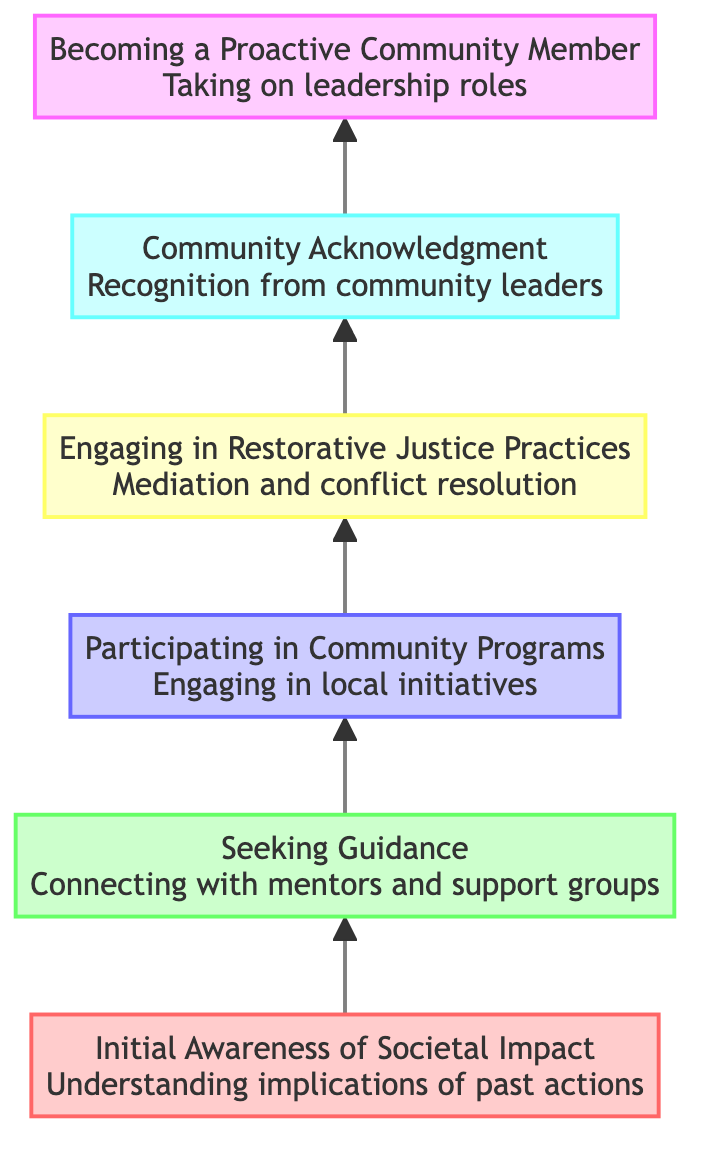What is the title of the top node in the diagram? The top node in the diagram represents the final step in the flow, which is "Becoming a Proactive Community Member"
Answer: Becoming a Proactive Community Member How many levels are represented in the diagram? The diagram consists of six distinct levels, ranging from 'Initial Awareness of Societal Impact' to 'Becoming a Proactive Community Member'
Answer: 6 What process directly follows "Engaging in Restorative Justice Practices"? The node that follows "Engaging in Restorative Justice Practices" in the upward flow is "Community Acknowledgment"
Answer: Community Acknowledgment Which node addresses community service programs? The node that focuses on community service initiatives is "Participating in Community Programs," which includes local initiatives and mentorship
Answer: Participating in Community Programs What is the main action represented at level 5 of the diagram? At level 5 of the diagram, the main action is "Community Acknowledgment," which involves receiving recognition from community leaders
Answer: Community Acknowledgment What is the first step in the process depicted in the diagram? The first step in the flow of the diagram is "Initial Awareness of Societal Impact," indicating the beginning of understanding one's impact
Answer: Initial Awareness of Societal Impact Which node follows after "Seeking Guidance"? Following "Seeking Guidance," the next node that appears is "Participating in Community Programs," indicating a progression in the process
Answer: Participating in Community Programs Which node indicates the culmination of the restorative justice initiative? The final node, indicating the culmination of the initiative, is "Becoming a Proactive Community Member," showing the ultimate goal of engagement
Answer: Becoming a Proactive Community Member 